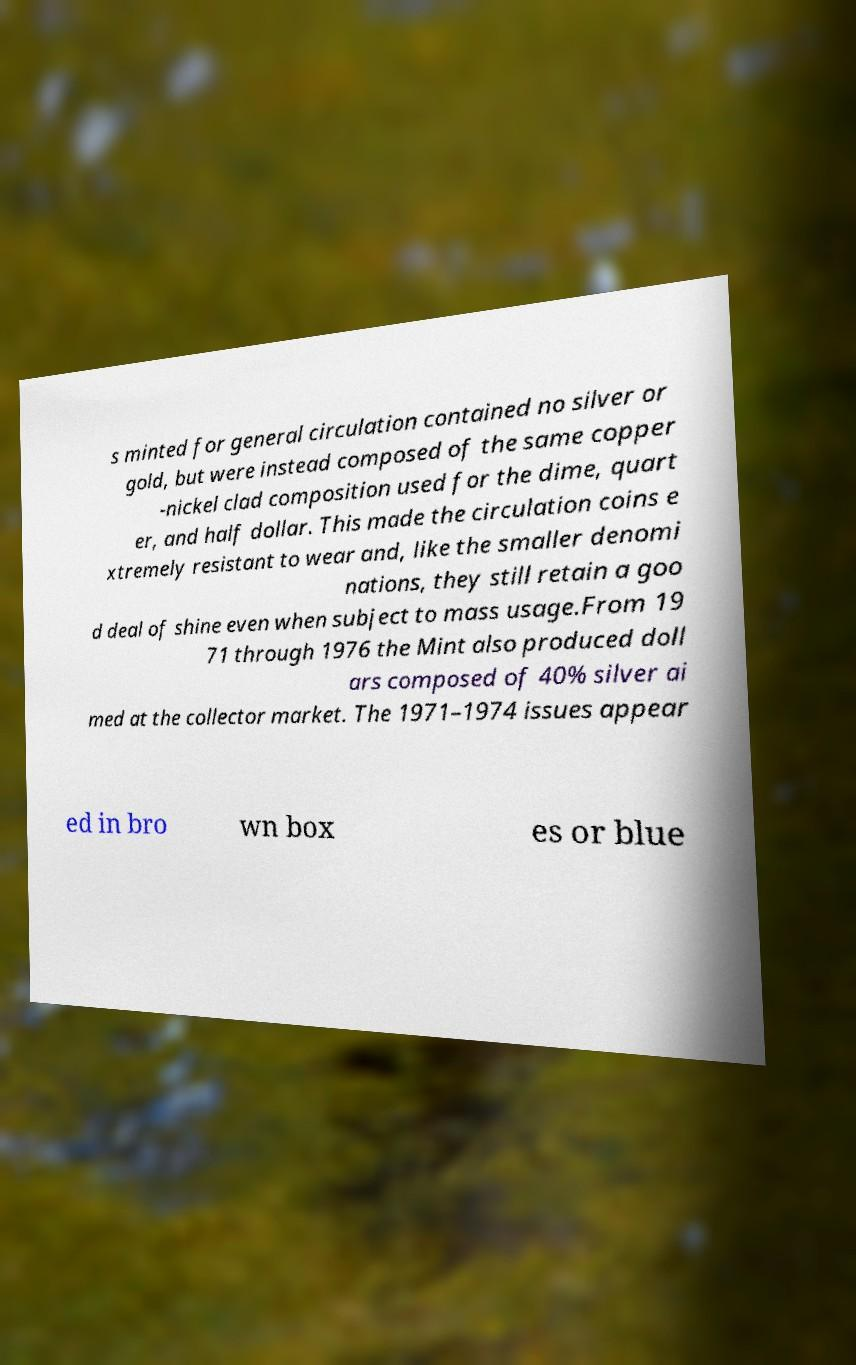Could you assist in decoding the text presented in this image and type it out clearly? s minted for general circulation contained no silver or gold, but were instead composed of the same copper -nickel clad composition used for the dime, quart er, and half dollar. This made the circulation coins e xtremely resistant to wear and, like the smaller denomi nations, they still retain a goo d deal of shine even when subject to mass usage.From 19 71 through 1976 the Mint also produced doll ars composed of 40% silver ai med at the collector market. The 1971–1974 issues appear ed in bro wn box es or blue 